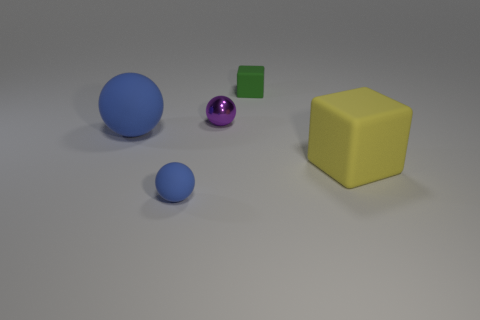There is a matte thing that is behind the large matte block and in front of the small matte block; what size is it?
Make the answer very short. Large. How many large yellow cubes are made of the same material as the large blue thing?
Keep it short and to the point. 1. How many balls are either green things or small matte objects?
Provide a succinct answer. 1. What is the size of the matte block that is right of the small matte object behind the cube that is in front of the tiny rubber block?
Keep it short and to the point. Large. What color is the small object that is in front of the green matte object and behind the large blue thing?
Ensure brevity in your answer.  Purple. There is a purple sphere; is its size the same as the rubber ball that is on the right side of the big rubber ball?
Offer a very short reply. Yes. Is there any other thing that has the same shape as the green rubber object?
Keep it short and to the point. Yes. What color is the other matte thing that is the same shape as the yellow thing?
Make the answer very short. Green. Does the purple thing have the same size as the green object?
Ensure brevity in your answer.  Yes. What number of other objects are the same size as the yellow thing?
Give a very brief answer. 1. 